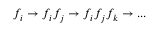Convert formula to latex. <formula><loc_0><loc_0><loc_500><loc_500>f _ { i } \to f _ { i } f _ { j } \to f _ { i } f _ { j } f _ { k } \to \dots</formula> 